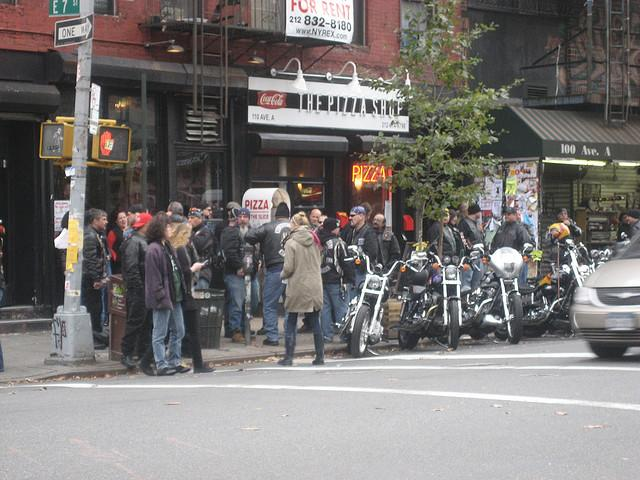What will the bikers shown here have for lunch today?

Choices:
A) hot dogs
B) steak
C) pizza
D) salads pizza 